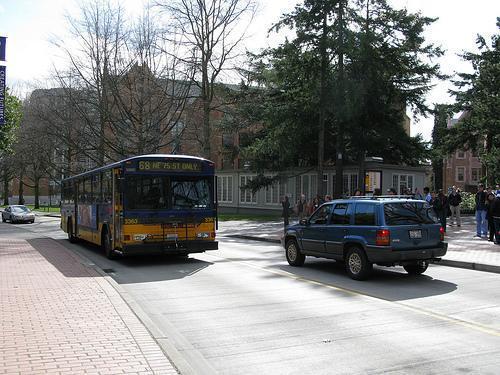How many trucks on the road?
Give a very brief answer. 1. How many buses?
Give a very brief answer. 1. How many jeeps?
Give a very brief answer. 1. How many vehicles are there behind the bus?
Give a very brief answer. 1. 